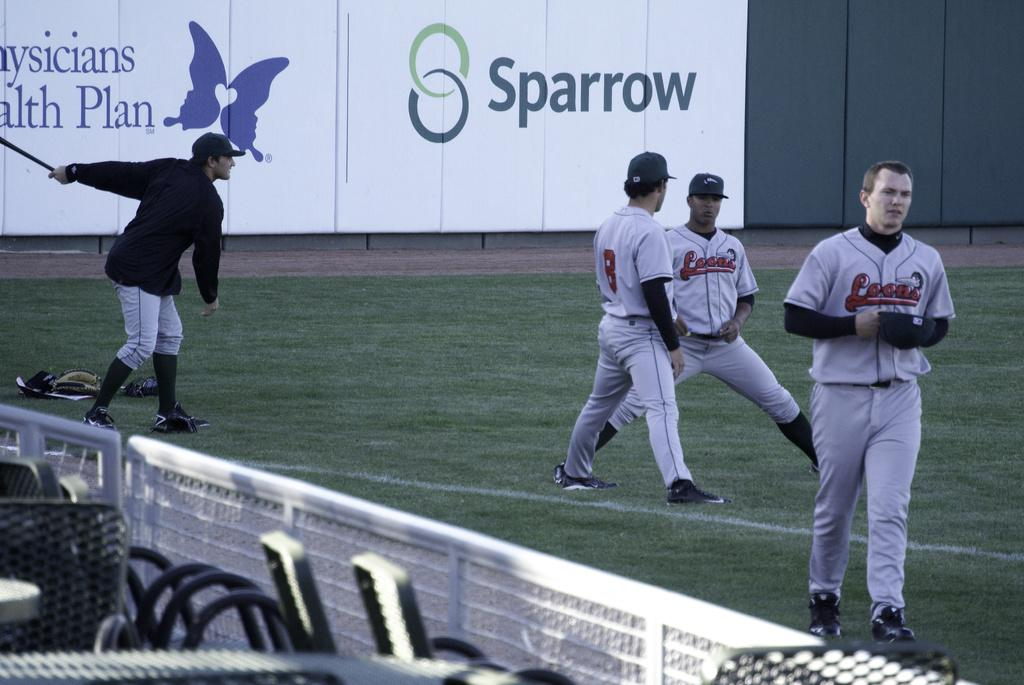<image>
Relay a brief, clear account of the picture shown. An advertisement for Sparrow behind a couple of baseball players 